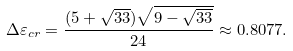<formula> <loc_0><loc_0><loc_500><loc_500>\Delta \varepsilon _ { c r } = \frac { ( 5 + \sqrt { 3 3 } ) \sqrt { 9 - \sqrt { 3 3 } } } { 2 4 } \approx 0 . 8 0 7 7 .</formula> 